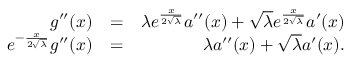<formula> <loc_0><loc_0><loc_500><loc_500>\begin{array} { r l r } { g ^ { \prime \prime } ( x ) } & { = } & { \lambda e ^ { \frac { x } { 2 \sqrt { \lambda } } } a ^ { \prime \prime } ( x ) + { \sqrt { \lambda } } e ^ { \frac { x } { 2 \sqrt { \lambda } } } a ^ { \prime } ( x ) } \\ { e ^ { - \frac { x } { 2 \sqrt { \lambda } } } g ^ { \prime \prime } ( x ) } & { = } & { \lambda a ^ { \prime \prime } ( x ) + { \sqrt { \lambda } } a ^ { \prime } ( x ) . } \end{array}</formula> 